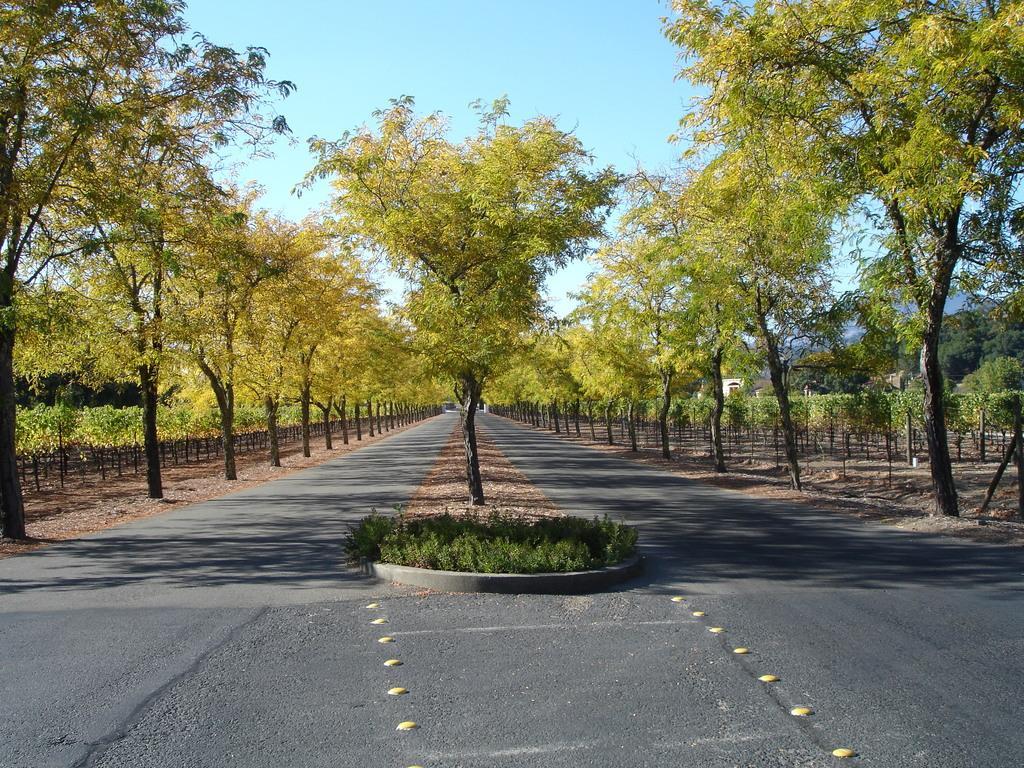In one or two sentences, can you explain what this image depicts? There are trees, this is road and a sky. 